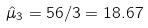<formula> <loc_0><loc_0><loc_500><loc_500>\hat { \mu } _ { 3 } = 5 6 / 3 = 1 8 . 6 7</formula> 